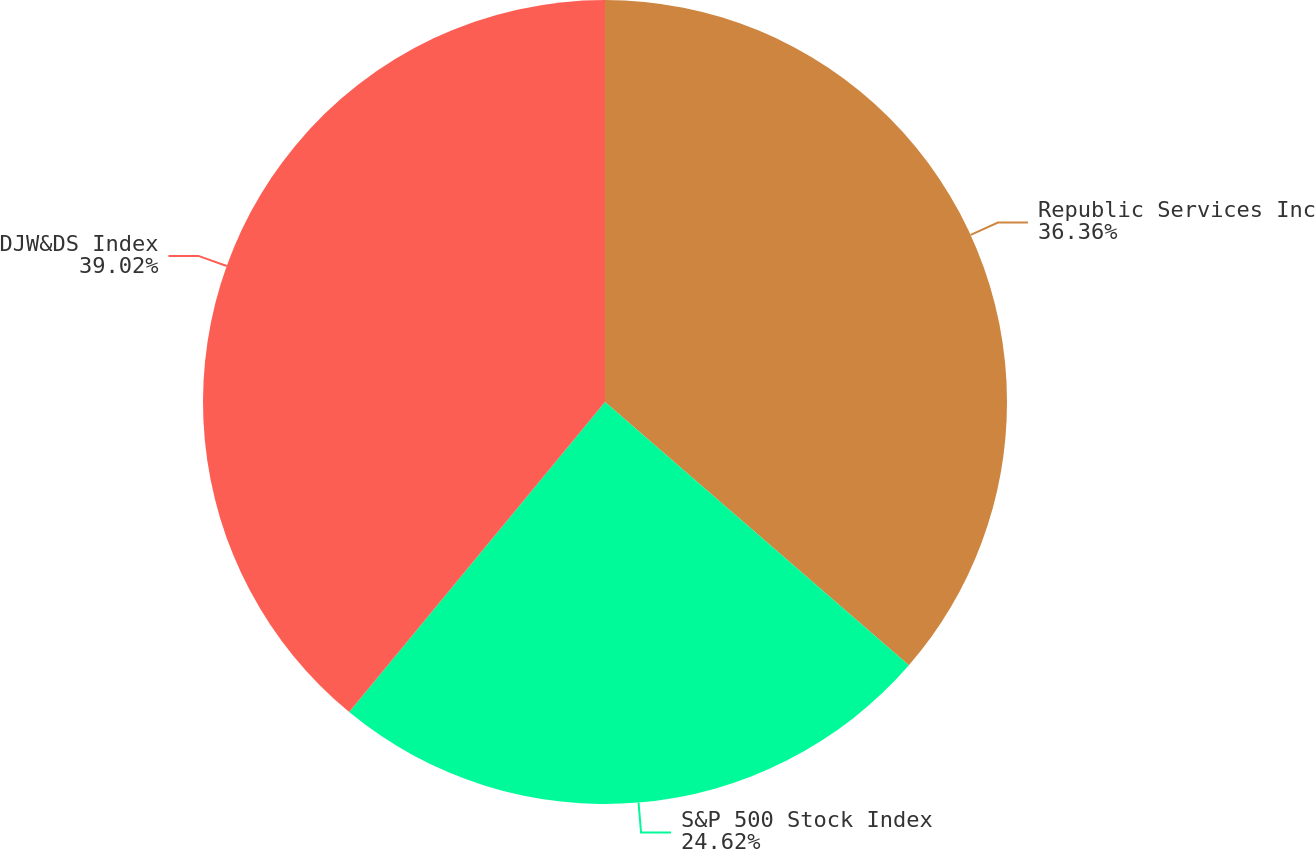Convert chart. <chart><loc_0><loc_0><loc_500><loc_500><pie_chart><fcel>Republic Services Inc<fcel>S&P 500 Stock Index<fcel>DJW&DS Index<nl><fcel>36.36%<fcel>24.62%<fcel>39.02%<nl></chart> 